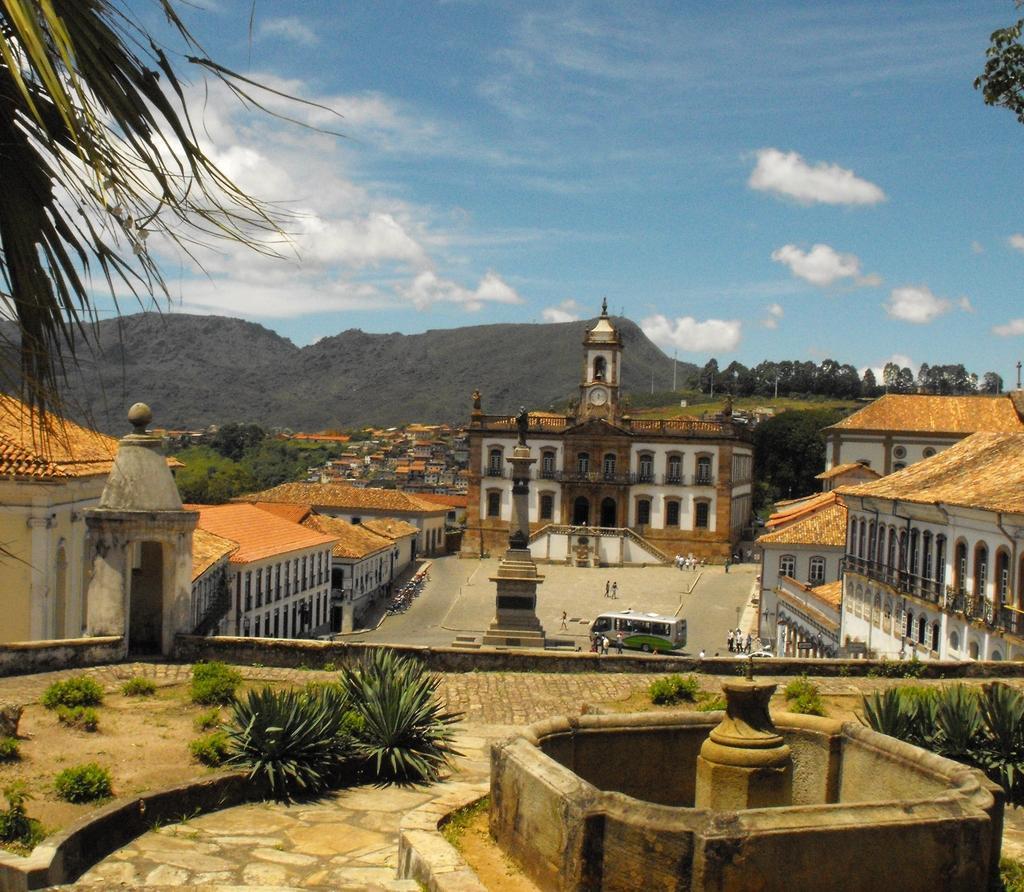How would you summarize this image in a sentence or two? In the picture I can see buildings, plants, trees and some other objects. In the background I can see people, a bus, the sky and some other objects. 